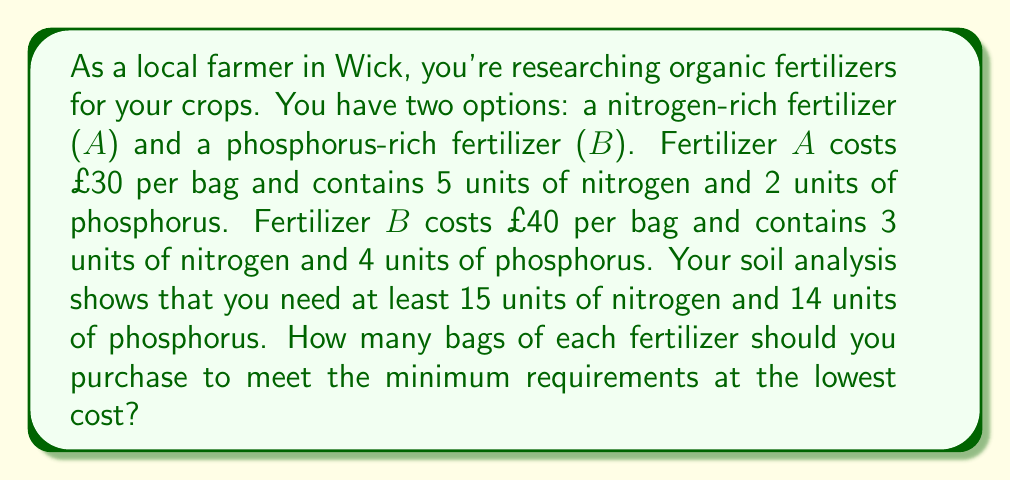Show me your answer to this math problem. Let's solve this step-by-step using a system of equations:

1) Let $x$ be the number of bags of fertilizer $A$ and $y$ be the number of bags of fertilizer $B$.

2) Set up the constraints based on the nutrient requirements:
   Nitrogen: $5x + 3y \geq 15$
   Phosphorus: $2x + 4y \geq 14$

3) The objective is to minimize the cost:
   $\text{Cost} = 30x + 40y$

4) We can solve this using the simplex method, but for a simpler approach, let's graph the inequalities:

   [asy]
   import graph;
   size(200);
   xaxis("x", 0, 8);
   yaxis("y", 0, 8);
   draw((0,5)--(3,0), blue);
   draw((0,3.5)--(7,0), red);
   label("5x + 3y = 15", (4,2), blue);
   label("2x + 4y = 14", (5,1), red);
   fill((0,5)--(3,0)--(7,0)--(0,3.5)--cycle, palegreen+opacity(0.2));
   dot((1,4));
   label("(1,4)", (1,4), NE);
   [/asy]

5) The feasible region is the area above both lines. The optimal solution will be at one of the corner points.

6) The corner points are (0,5), (1,4), and (3,2). Let's calculate the cost for each:
   (0,5): $30(0) + 40(5) = £200$
   (1,4): $30(1) + 40(4) = £190$
   (3,2): $30(3) + 40(2) = £170$

7) The minimum cost is £170, corresponding to 3 bags of fertilizer $A$ and 2 bags of fertilizer $B$.
Answer: 3 bags of fertilizer $A$ and 2 bags of fertilizer $B$ 